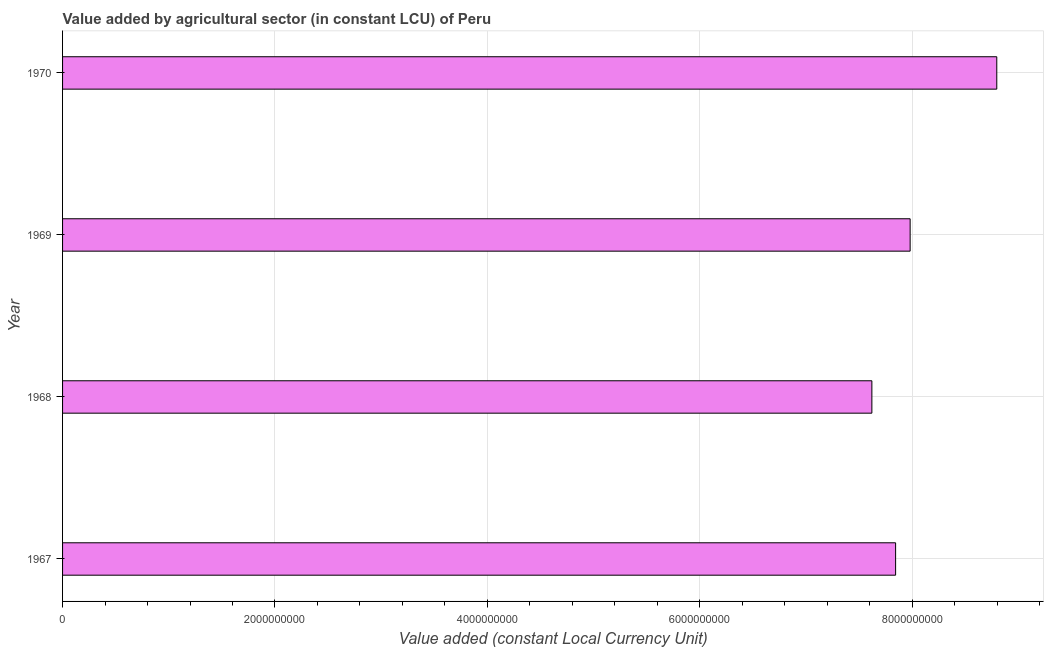Does the graph contain any zero values?
Provide a succinct answer. No. Does the graph contain grids?
Provide a succinct answer. Yes. What is the title of the graph?
Provide a succinct answer. Value added by agricultural sector (in constant LCU) of Peru. What is the label or title of the X-axis?
Provide a succinct answer. Value added (constant Local Currency Unit). What is the label or title of the Y-axis?
Give a very brief answer. Year. What is the value added by agriculture sector in 1967?
Ensure brevity in your answer.  7.84e+09. Across all years, what is the maximum value added by agriculture sector?
Provide a short and direct response. 8.80e+09. Across all years, what is the minimum value added by agriculture sector?
Offer a terse response. 7.62e+09. In which year was the value added by agriculture sector maximum?
Provide a short and direct response. 1970. In which year was the value added by agriculture sector minimum?
Offer a terse response. 1968. What is the sum of the value added by agriculture sector?
Make the answer very short. 3.22e+1. What is the difference between the value added by agriculture sector in 1967 and 1970?
Provide a succinct answer. -9.53e+08. What is the average value added by agriculture sector per year?
Your response must be concise. 8.06e+09. What is the median value added by agriculture sector?
Provide a succinct answer. 7.91e+09. Is the value added by agriculture sector in 1968 less than that in 1970?
Your response must be concise. Yes. What is the difference between the highest and the second highest value added by agriculture sector?
Provide a short and direct response. 8.16e+08. Is the sum of the value added by agriculture sector in 1968 and 1970 greater than the maximum value added by agriculture sector across all years?
Your response must be concise. Yes. What is the difference between the highest and the lowest value added by agriculture sector?
Make the answer very short. 1.18e+09. In how many years, is the value added by agriculture sector greater than the average value added by agriculture sector taken over all years?
Ensure brevity in your answer.  1. How many bars are there?
Your answer should be compact. 4. What is the Value added (constant Local Currency Unit) in 1967?
Offer a very short reply. 7.84e+09. What is the Value added (constant Local Currency Unit) in 1968?
Make the answer very short. 7.62e+09. What is the Value added (constant Local Currency Unit) of 1969?
Your response must be concise. 7.98e+09. What is the Value added (constant Local Currency Unit) of 1970?
Your answer should be very brief. 8.80e+09. What is the difference between the Value added (constant Local Currency Unit) in 1967 and 1968?
Offer a terse response. 2.24e+08. What is the difference between the Value added (constant Local Currency Unit) in 1967 and 1969?
Provide a short and direct response. -1.37e+08. What is the difference between the Value added (constant Local Currency Unit) in 1967 and 1970?
Your answer should be compact. -9.53e+08. What is the difference between the Value added (constant Local Currency Unit) in 1968 and 1969?
Your response must be concise. -3.60e+08. What is the difference between the Value added (constant Local Currency Unit) in 1968 and 1970?
Keep it short and to the point. -1.18e+09. What is the difference between the Value added (constant Local Currency Unit) in 1969 and 1970?
Ensure brevity in your answer.  -8.16e+08. What is the ratio of the Value added (constant Local Currency Unit) in 1967 to that in 1969?
Provide a succinct answer. 0.98. What is the ratio of the Value added (constant Local Currency Unit) in 1967 to that in 1970?
Keep it short and to the point. 0.89. What is the ratio of the Value added (constant Local Currency Unit) in 1968 to that in 1969?
Provide a short and direct response. 0.95. What is the ratio of the Value added (constant Local Currency Unit) in 1968 to that in 1970?
Provide a short and direct response. 0.87. What is the ratio of the Value added (constant Local Currency Unit) in 1969 to that in 1970?
Make the answer very short. 0.91. 